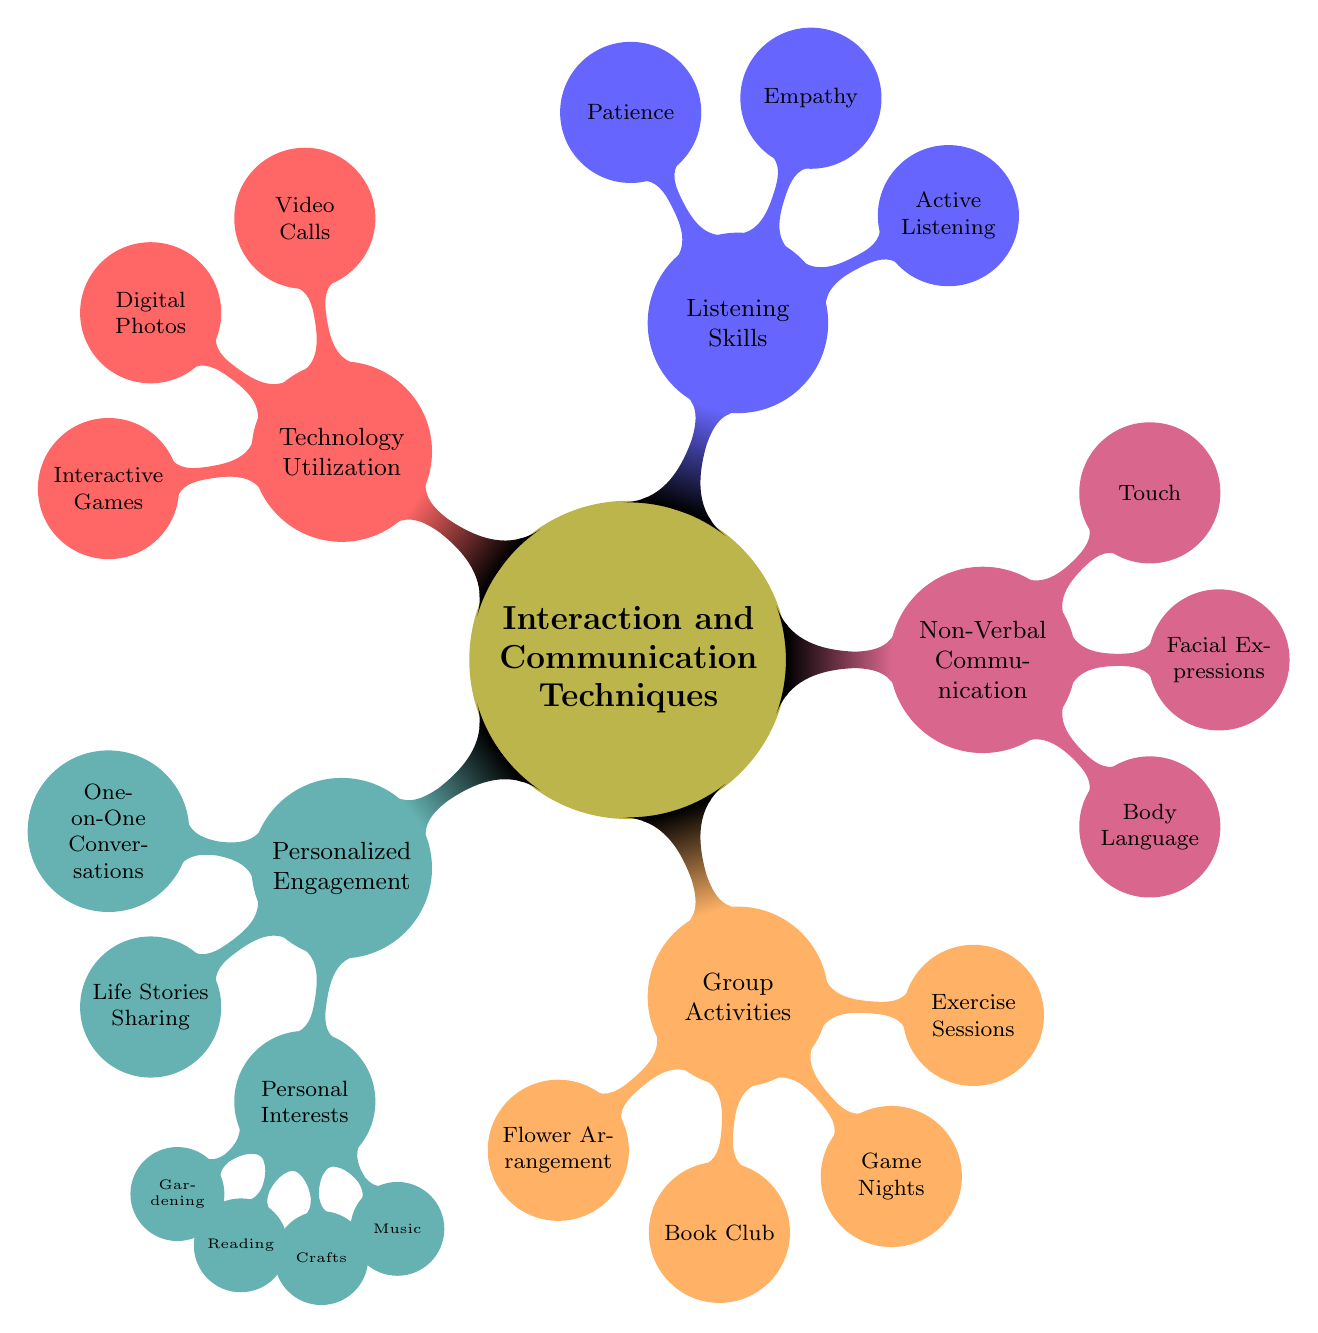What's the main topic of the mind map? The main topic is represented at the center of the diagram and labeled "Interaction and Communication Techniques with Elderly Residents".
Answer: Interaction and Communication Techniques with Elderly Residents How many main branches stem from the central topic? By counting the child nodes that directly connect to the central node, there are five main branches: Personalized Engagement, Group Activities, Non-Verbal Communication, Listening Skills, and Technology Utilization.
Answer: 5 Which branch includes "Flower Arrangement Workshops"? "Flower Arrangement Workshops" falls under the branch labeled "Group Activities", as it is listed as one of the nodes under that category.
Answer: Group Activities What is the relationship between "Active Listening" and "Listening Skills"? "Active Listening" is a child node under the branch labeled "Listening Skills", indicating that it is a specific technique related to listening.
Answer: Child node What personal interest is NOT mentioned in the diagram? The diagram lists Gardening, Reading, Crafts, and Music; therefore, interests such as Sports or Cooking are not mentioned.
Answer: Sports (or Cooking) Which technique focuses on "Touch and Physical Contact"? The technique focusing on "Touch and Physical Contact" is categorized under "Non-Verbal Communication", indicating its relevance in that context.
Answer: Non-Verbal Communication How many specific techniques does the "Technology Utilization" branch contain? Within the "Technology Utilization" branch, there are three specific techniques listed: Video Calls with Family, Digital Photo Albums, and Interactive Games.
Answer: 3 Which activity is likely to involve collaboration among residents? The "Group Activities" branch suggests that activities like "Game Nights" are likely to involve collaboration among residents, as they are typically participatory in nature.
Answer: Game Nights In which branch would you find "Empathy and Understanding"? "Empathy and Understanding" is a child node under the "Listening Skills" branch, indicating it is included within the context of effective listening techniques.
Answer: Listening Skills 